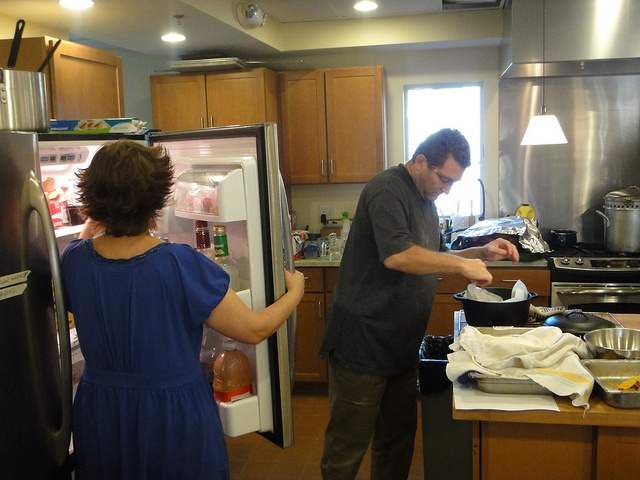Describe the objects in this image and their specific colors. I can see refrigerator in tan, black, gray, and maroon tones, people in tan, black, navy, olive, and maroon tones, people in tan, black, gray, and maroon tones, oven in tan, black, gray, darkgreen, and olive tones, and bowl in tan, black, darkgray, and gray tones in this image. 